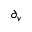Convert formula to latex. <formula><loc_0><loc_0><loc_500><loc_500>\partial _ { v }</formula> 